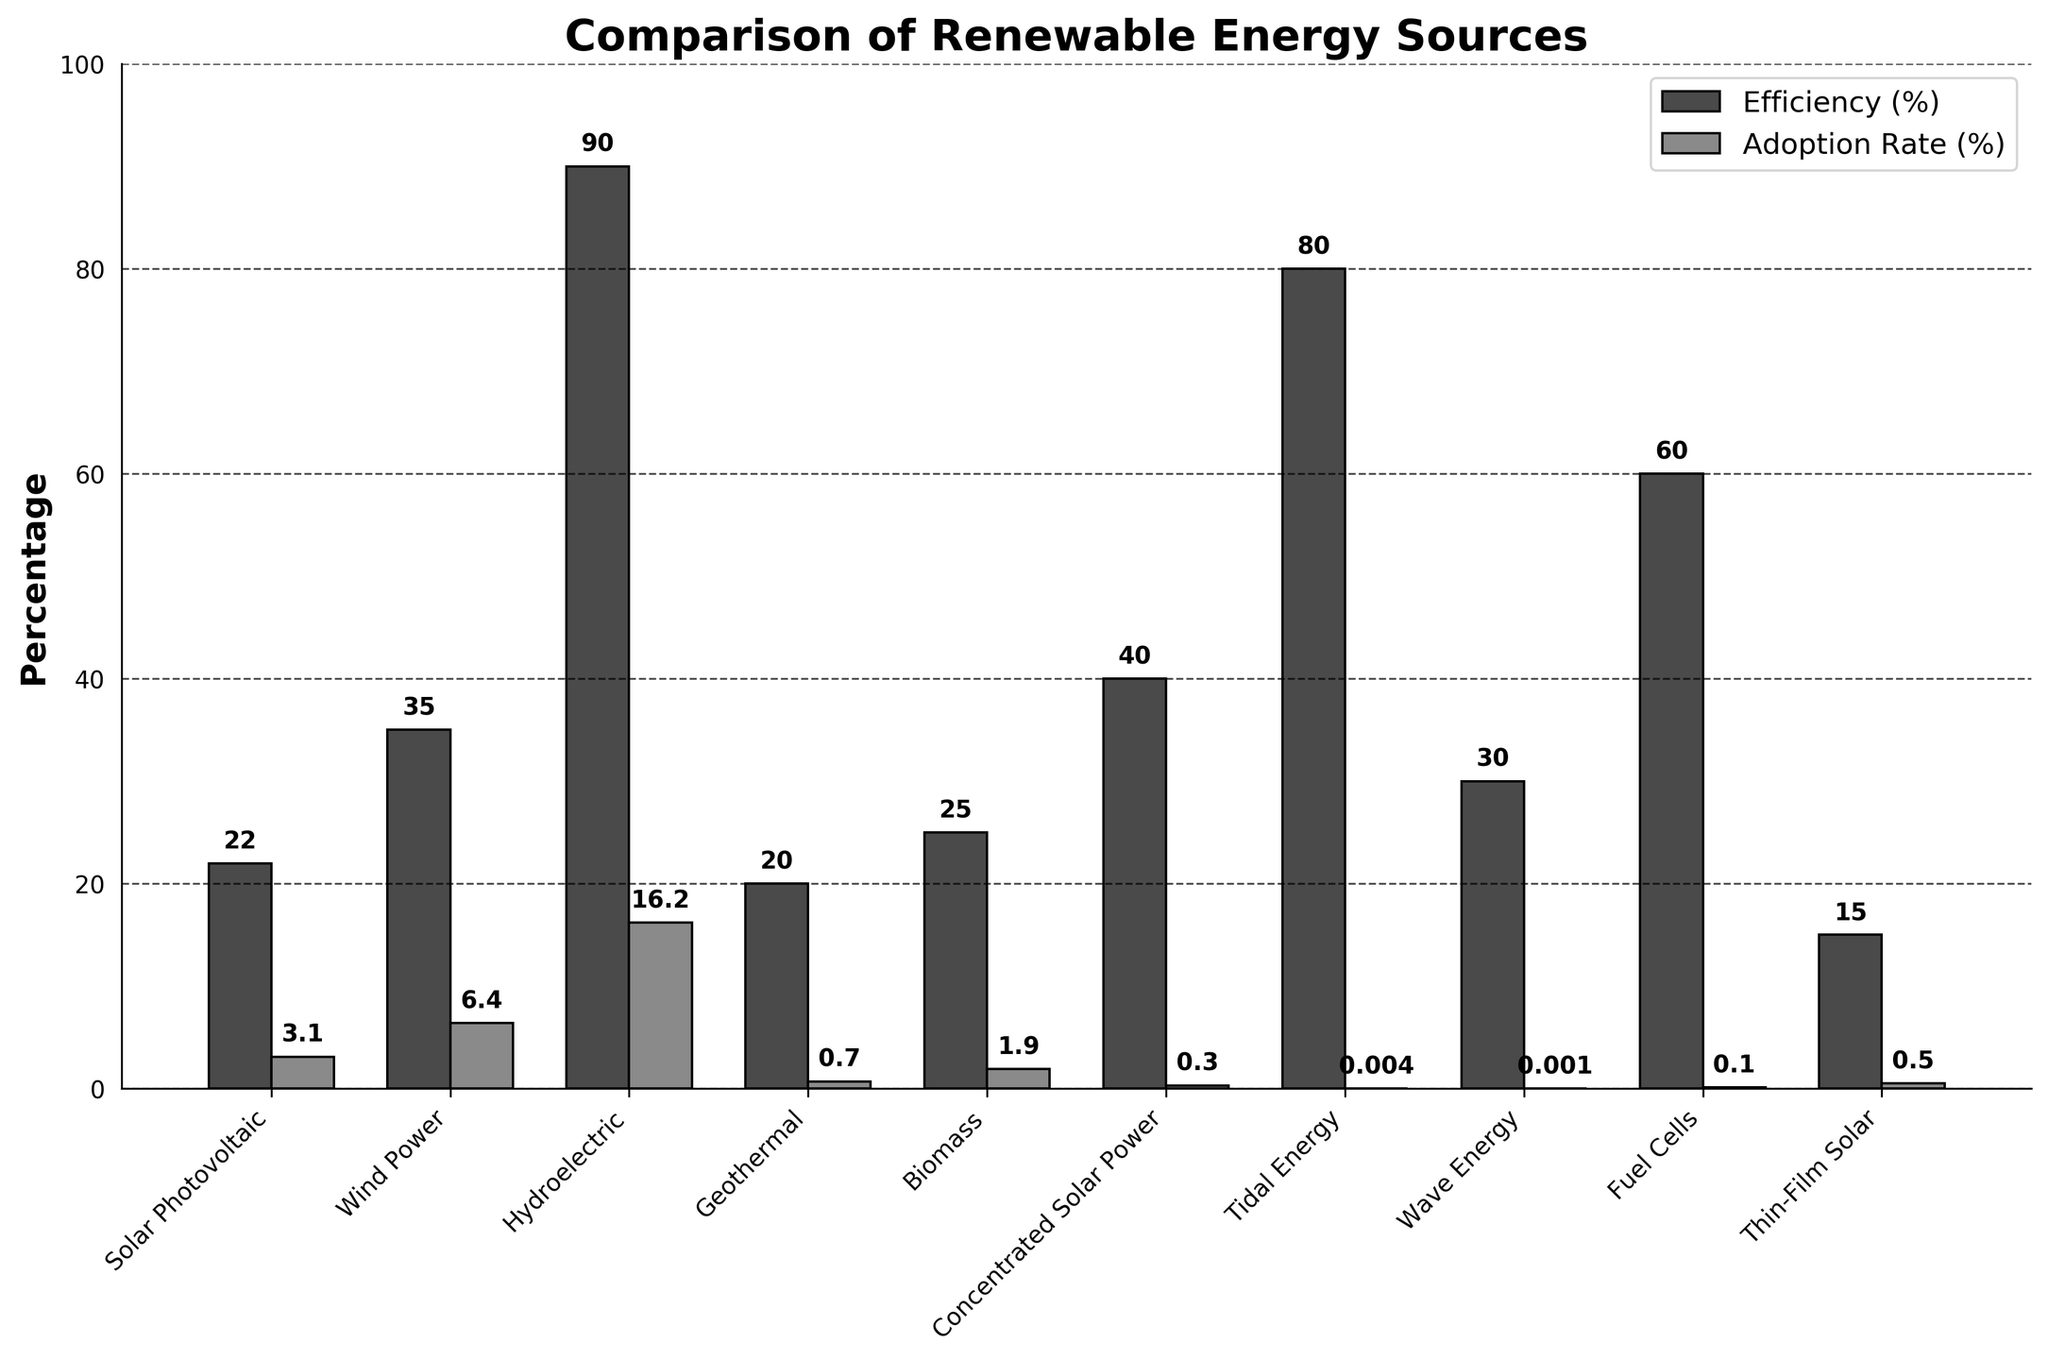Which energy source has the highest efficiency? The 'Efficiency (%)' bar with the highest value belongs to Hydroelectric, at 90%.
Answer: Hydroelectric Which energy source has the lowest adoption rate? The 'Adoption Rate (%)' bar with the lowest value is for Wave Energy, at 0.001%.
Answer: Wave Energy How much higher is the efficiency of Fuel Cells compared to Geothermal energy? Fuel Cells have an efficiency of 60% and Geothermal energy has 20%, so the difference is 60 - 20 = 40%.
Answer: 40% Which two energy sources have the closest adoption rates? Comparing the 'Adoption Rate (%)' bars, Solar Photovoltaic (3.1%) and Biomass (1.9%) are closer to each other than others.
Answer: Solar Photovoltaic and Biomass What is the total adoption rate percentage for Solar Photovoltaic, Wind Power, and Hydroelectric combined? Solar Photovoltaic has 3.1%, Wind Power has 6.4%, and Hydroelectric has 16.2%. Sum them up: 3.1 + 6.4 + 16.2 = 25.7%.
Answer: 25.7% Which energy source has a significantly higher efficiency compared to its adoption rate? Hydroelectric has a high efficiency (90%) and a relatively lower adoption rate (16.2%).
Answer: Hydroelectric Are there any energy sources with an efficiency below 25% but an adoption rate above 1%? Biomass has an efficiency of 25% and adoption rate of 1.9%.
Answer: Biomass What is the average efficiency of all the energy sources shown? Sum the efficiencies: 22 + 35 + 90 + 20 + 25 + 40 + 80 + 30 + 60 + 15 = 417. There are 10 sources, so the average is 417 / 10 = 41.7%.
Answer: 41.7% Which energy source has an efficiency close to the average efficiency of all sources? The calculated average efficiency is 41.7%. Concentrated Solar Power has an efficiency of 40%, which is closest.
Answer: Concentrated Solar Power 